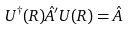<formula> <loc_0><loc_0><loc_500><loc_500>U ^ { \dagger } ( R ) \hat { A } ^ { \prime } U ( R ) = \hat { A }</formula> 